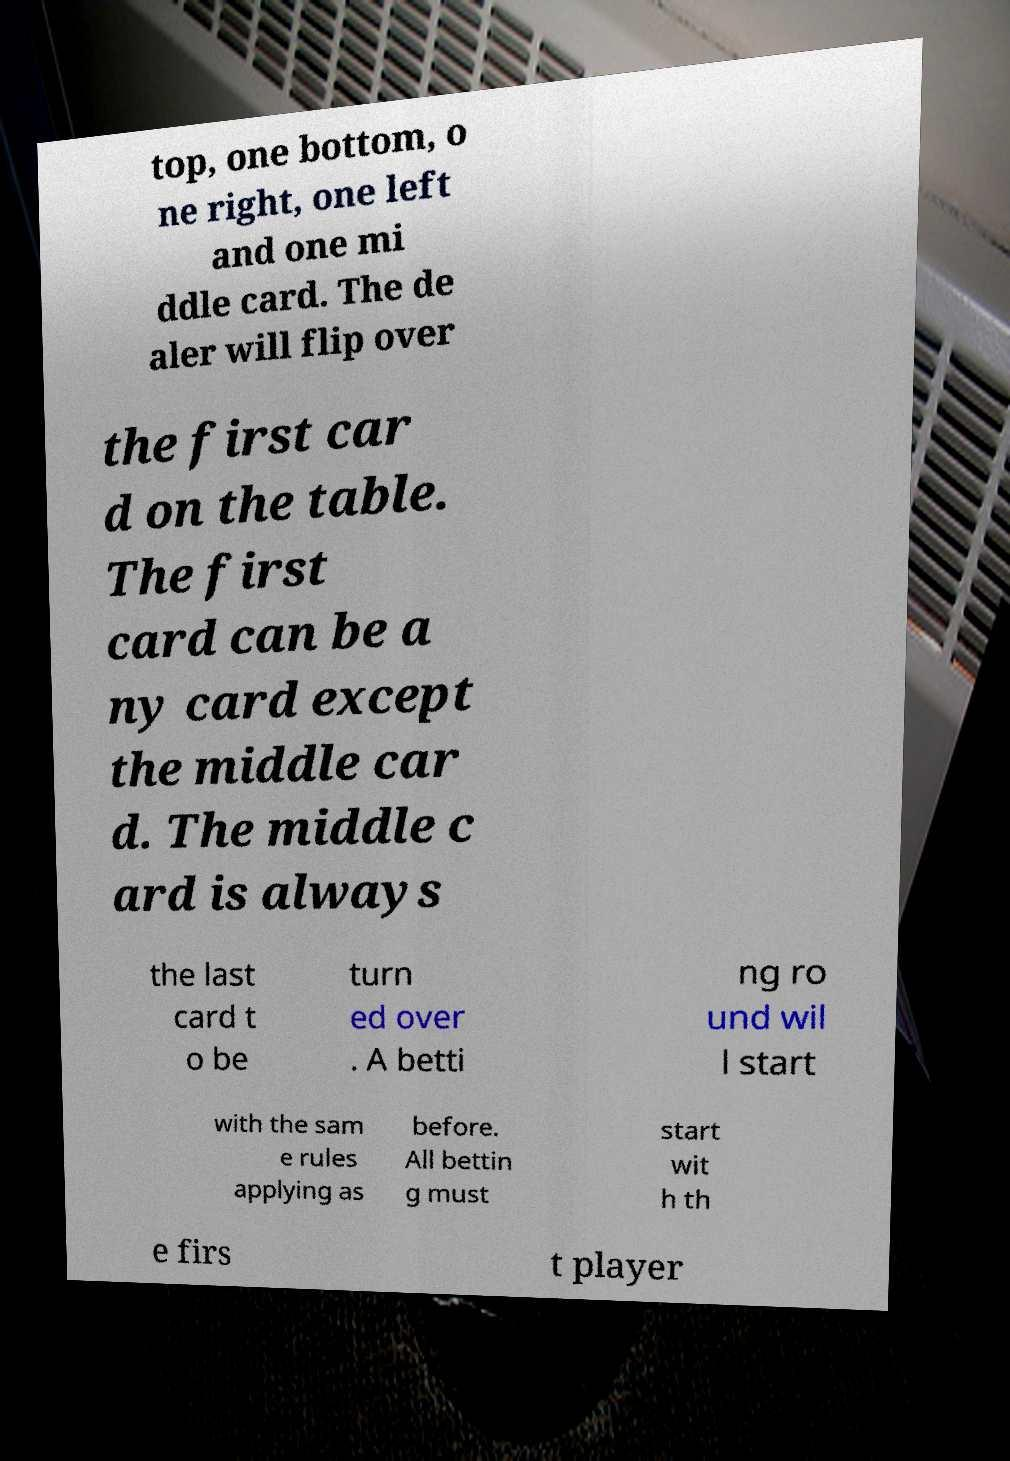Please read and relay the text visible in this image. What does it say? top, one bottom, o ne right, one left and one mi ddle card. The de aler will flip over the first car d on the table. The first card can be a ny card except the middle car d. The middle c ard is always the last card t o be turn ed over . A betti ng ro und wil l start with the sam e rules applying as before. All bettin g must start wit h th e firs t player 